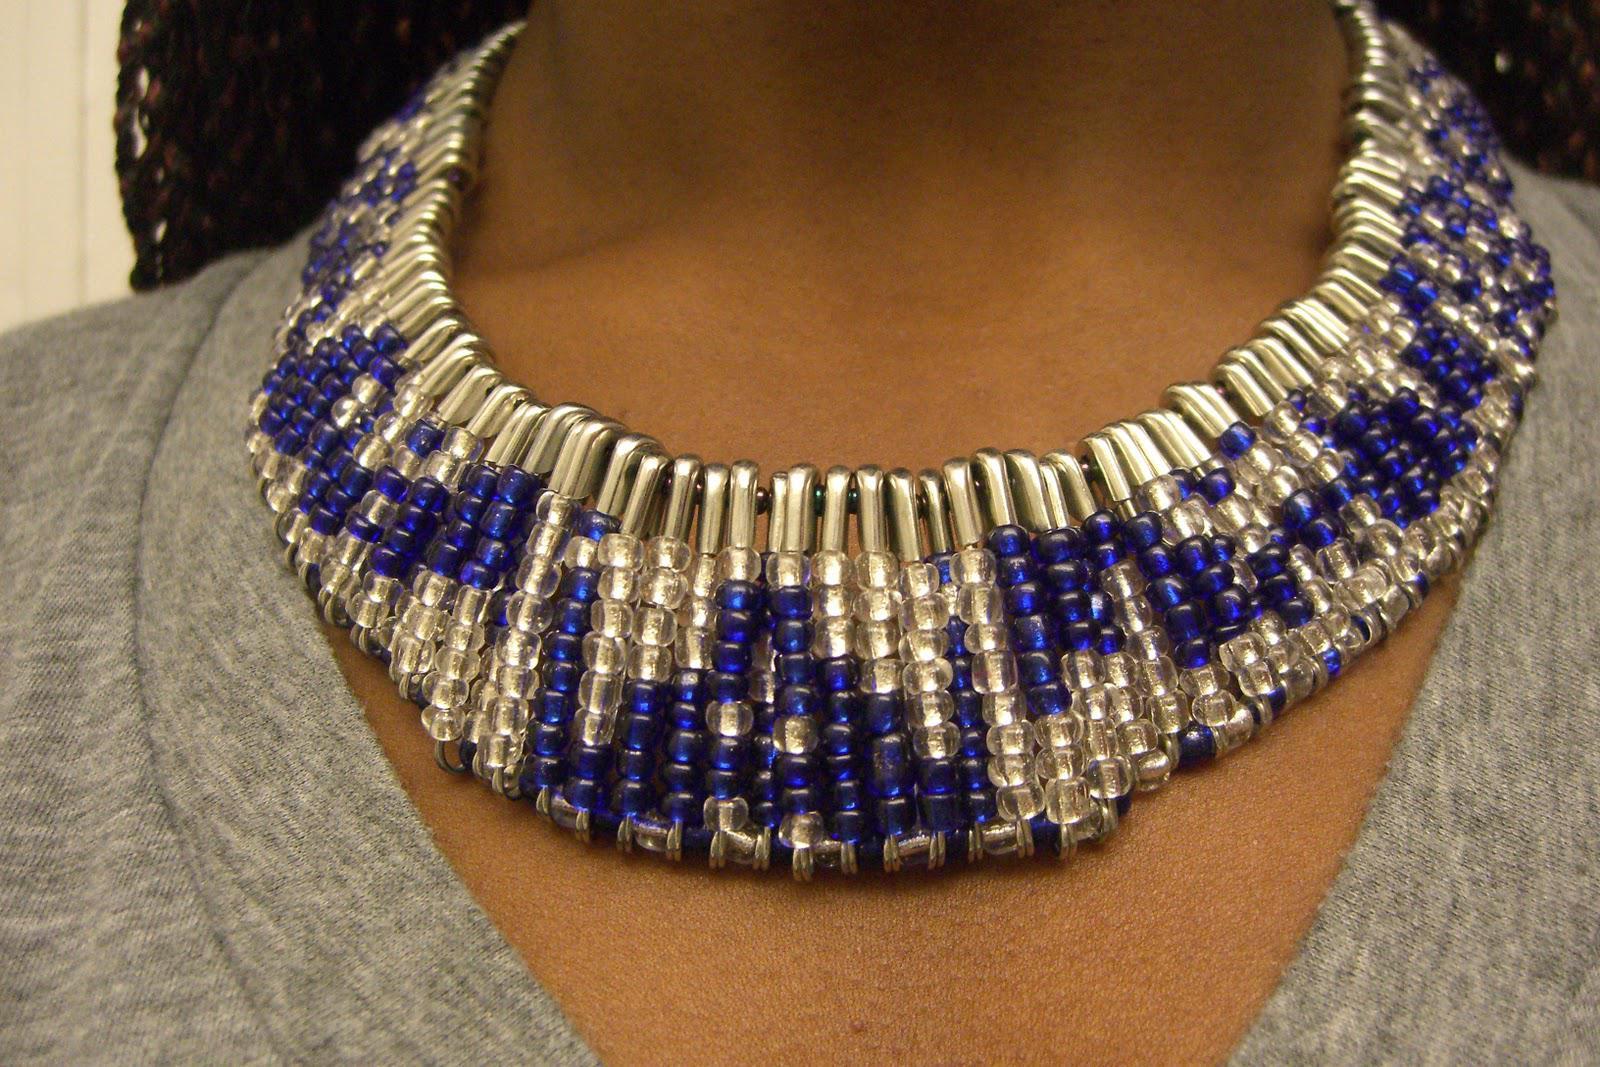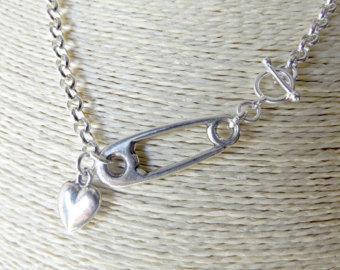The first image is the image on the left, the second image is the image on the right. Assess this claim about the two images: "A necklace shown on a neck contains a pattern of square shapes made by repeating safety pin rows and contains gold and silver pins without beads strung on them.". Correct or not? Answer yes or no. No. 